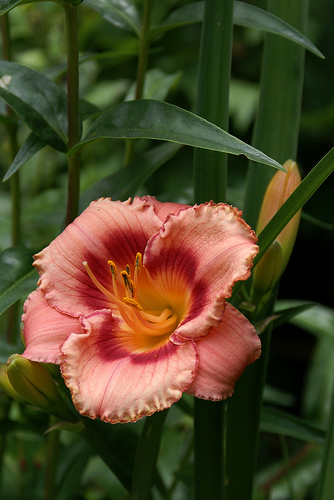<image>
Is the flower on the leaf? Yes. Looking at the image, I can see the flower is positioned on top of the leaf, with the leaf providing support. 